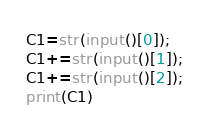<code> <loc_0><loc_0><loc_500><loc_500><_Python_>C1=str(input()[0]);
C1+=str(input()[1]);
C1+=str(input()[2]);
print(C1)</code> 